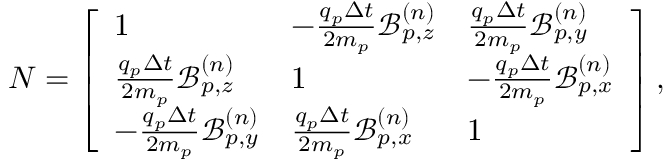Convert formula to latex. <formula><loc_0><loc_0><loc_500><loc_500>N = \left [ \begin{array} { l l l } { 1 } & { - \frac { q _ { p } \Delta t } { 2 m _ { p } } \mathcal { B } _ { p , z } ^ { ( n ) } } & { \frac { q _ { p } \Delta t } { 2 m _ { p } } \mathcal { B } _ { p , y } ^ { ( n ) } } \\ { \frac { q _ { p } \Delta t } { 2 m _ { p } } \mathcal { B } _ { p , z } ^ { ( n ) } } & { 1 } & { - \frac { q _ { p } \Delta t } { 2 m _ { p } } \mathcal { B } _ { p , x } ^ { ( n ) } } \\ { - \frac { q _ { p } \Delta t } { 2 m _ { p } } \mathcal { B } _ { p , y } ^ { ( n ) } } & { \frac { q _ { p } \Delta t } { 2 m _ { p } } \mathcal { B } _ { p , x } ^ { ( n ) } } & { 1 } \end{array} \right ] ,</formula> 